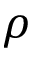Convert formula to latex. <formula><loc_0><loc_0><loc_500><loc_500>\rho</formula> 